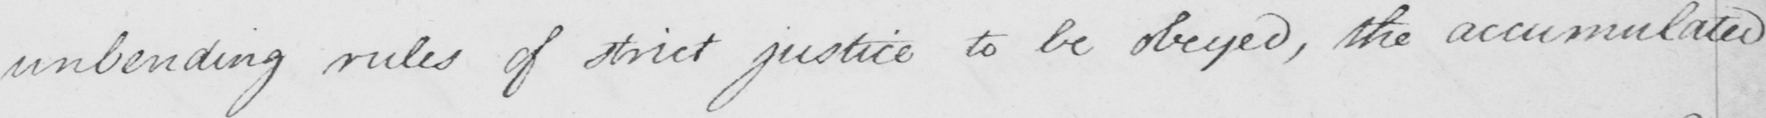What text is written in this handwritten line? unbending rules of strict justice to be obeyed , the accumulated 